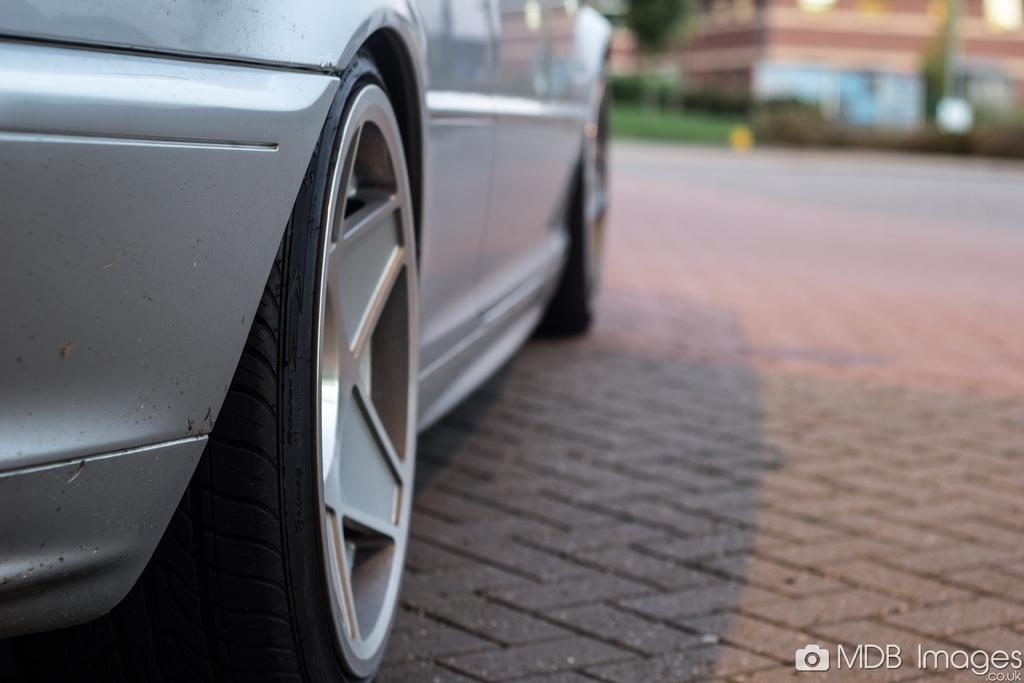What is the main subject of the image? The main subject of the image is a car. Where is the car located in the image? The car is on the left side of the image. What can be found in the right bottom corner of the image? There is text in the right bottom corner of the image. How would you describe the background of the image? The background of the image is blurred. What type of oven is being used in the discussion with the hen in the image? There is no oven or hen present in the image; it features a car and text in the background. 